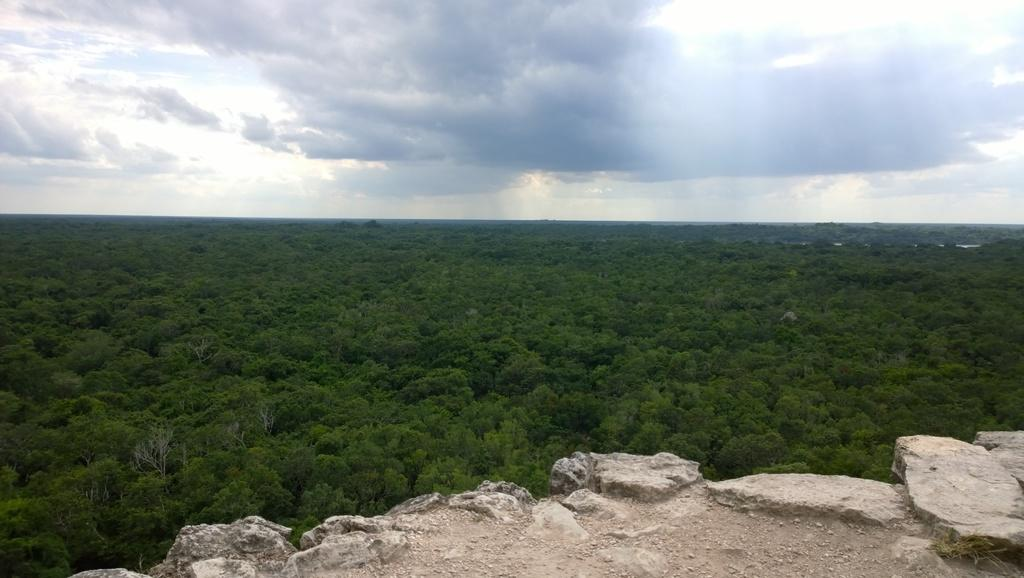What type of vegetation can be seen in the image? There are trees in the image. What other natural elements are present in the image? There are rocks in the image. What is visible in the background of the image? The sky is visible in the image. What can be seen in the sky? Clouds are present in the sky. Can you tell me where the guitar is located in the image? There is no guitar present in the image. What type of grass can be seen growing near the rocks in the image? There is no grass visible in the image; only trees, rocks, and the sky are present. 